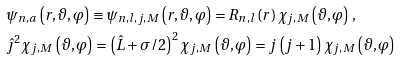<formula> <loc_0><loc_0><loc_500><loc_500>& \psi _ { n , a } \left ( r , \vartheta , \varphi \right ) \equiv \psi _ { n , l , j , M } \left ( r , \vartheta , \varphi \right ) = R _ { n , l } \left ( r \right ) \chi _ { j , M } \left ( \vartheta , \varphi \right ) \, , \\ & \hat { \jmath } ^ { 2 } \chi _ { j , M } \left ( \vartheta , \varphi \right ) = \left ( \hat { L } + \sigma / 2 \right ) ^ { 2 } \chi _ { j , M } \left ( \vartheta , \varphi \right ) = j \left ( j + 1 \right ) \chi _ { j , M } \left ( \vartheta , \varphi \right )</formula> 